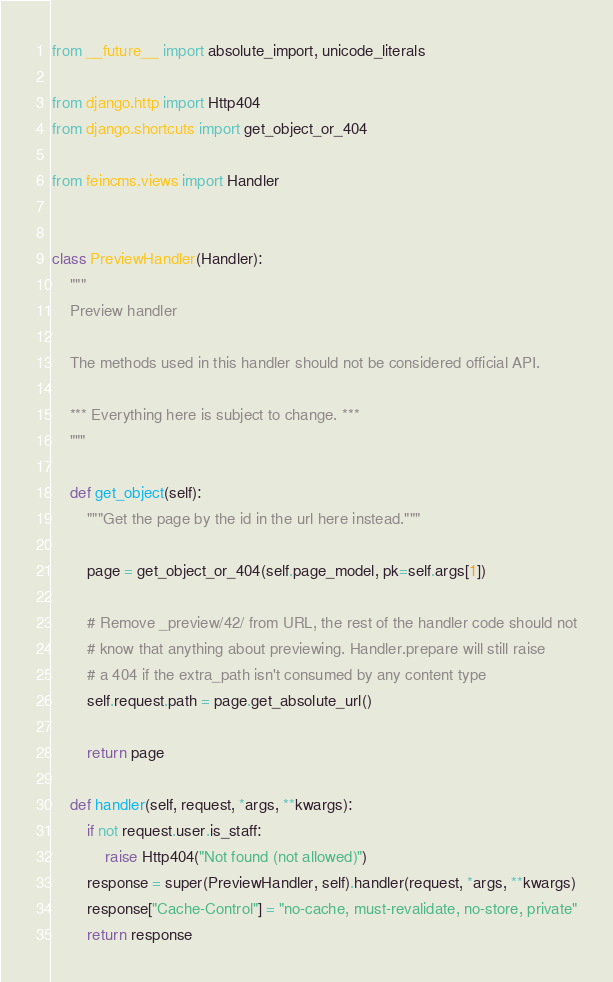<code> <loc_0><loc_0><loc_500><loc_500><_Python_>from __future__ import absolute_import, unicode_literals

from django.http import Http404
from django.shortcuts import get_object_or_404

from feincms.views import Handler


class PreviewHandler(Handler):
    """
    Preview handler

    The methods used in this handler should not be considered official API.

    *** Everything here is subject to change. ***
    """

    def get_object(self):
        """Get the page by the id in the url here instead."""

        page = get_object_or_404(self.page_model, pk=self.args[1])

        # Remove _preview/42/ from URL, the rest of the handler code should not
        # know that anything about previewing. Handler.prepare will still raise
        # a 404 if the extra_path isn't consumed by any content type
        self.request.path = page.get_absolute_url()

        return page

    def handler(self, request, *args, **kwargs):
        if not request.user.is_staff:
            raise Http404("Not found (not allowed)")
        response = super(PreviewHandler, self).handler(request, *args, **kwargs)
        response["Cache-Control"] = "no-cache, must-revalidate, no-store, private"
        return response
</code> 